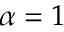<formula> <loc_0><loc_0><loc_500><loc_500>\alpha = 1</formula> 